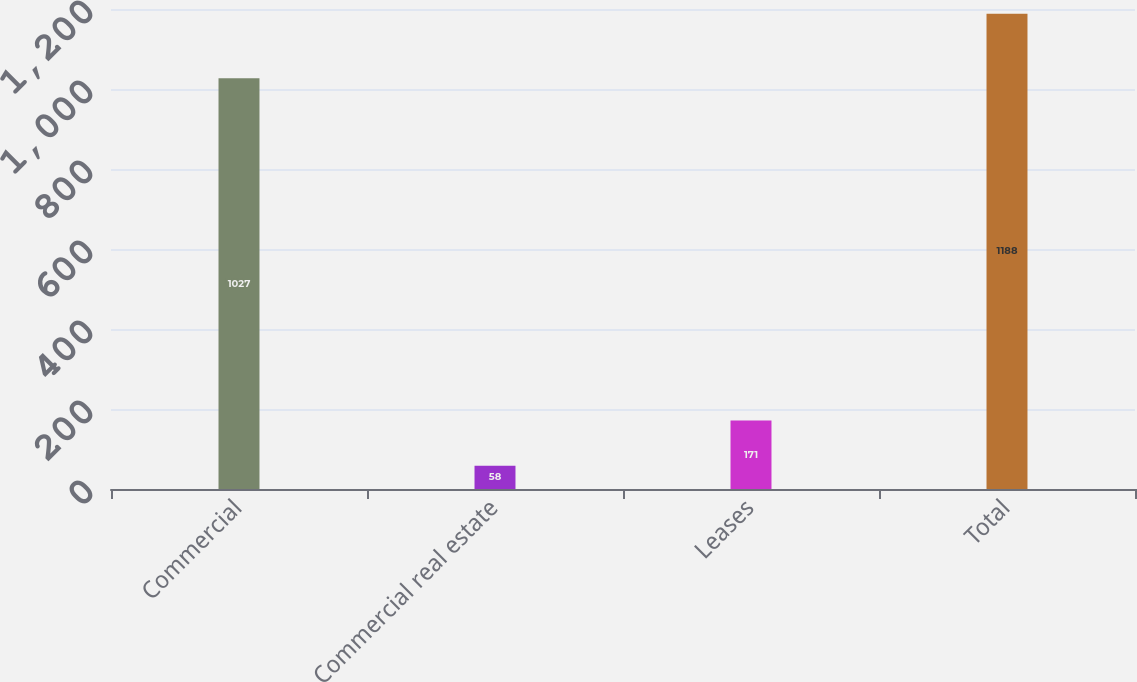Convert chart to OTSL. <chart><loc_0><loc_0><loc_500><loc_500><bar_chart><fcel>Commercial<fcel>Commercial real estate<fcel>Leases<fcel>Total<nl><fcel>1027<fcel>58<fcel>171<fcel>1188<nl></chart> 